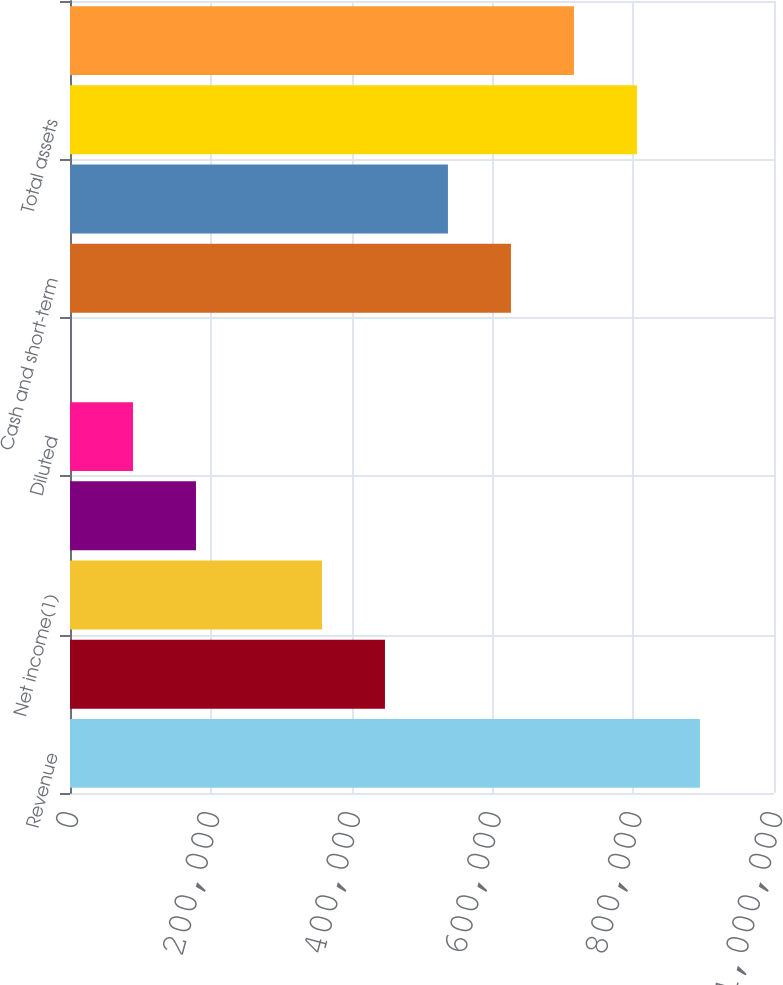Convert chart. <chart><loc_0><loc_0><loc_500><loc_500><bar_chart><fcel>Revenue<fcel>Income before income taxes<fcel>Net income(1)<fcel>Basic<fcel>Diluted<fcel>Cash dividends declared per<fcel>Cash and short-term<fcel>Working capital<fcel>Total assets<fcel>Stockholders' equity<nl><fcel>894791<fcel>447396<fcel>357916<fcel>178958<fcel>89479.2<fcel>0.1<fcel>626354<fcel>536875<fcel>805312<fcel>715833<nl></chart> 